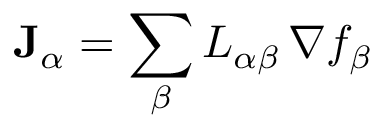<formula> <loc_0><loc_0><loc_500><loc_500>J _ { \alpha } = \sum _ { \beta } L _ { \alpha \beta } \, \nabla f _ { \beta }</formula> 